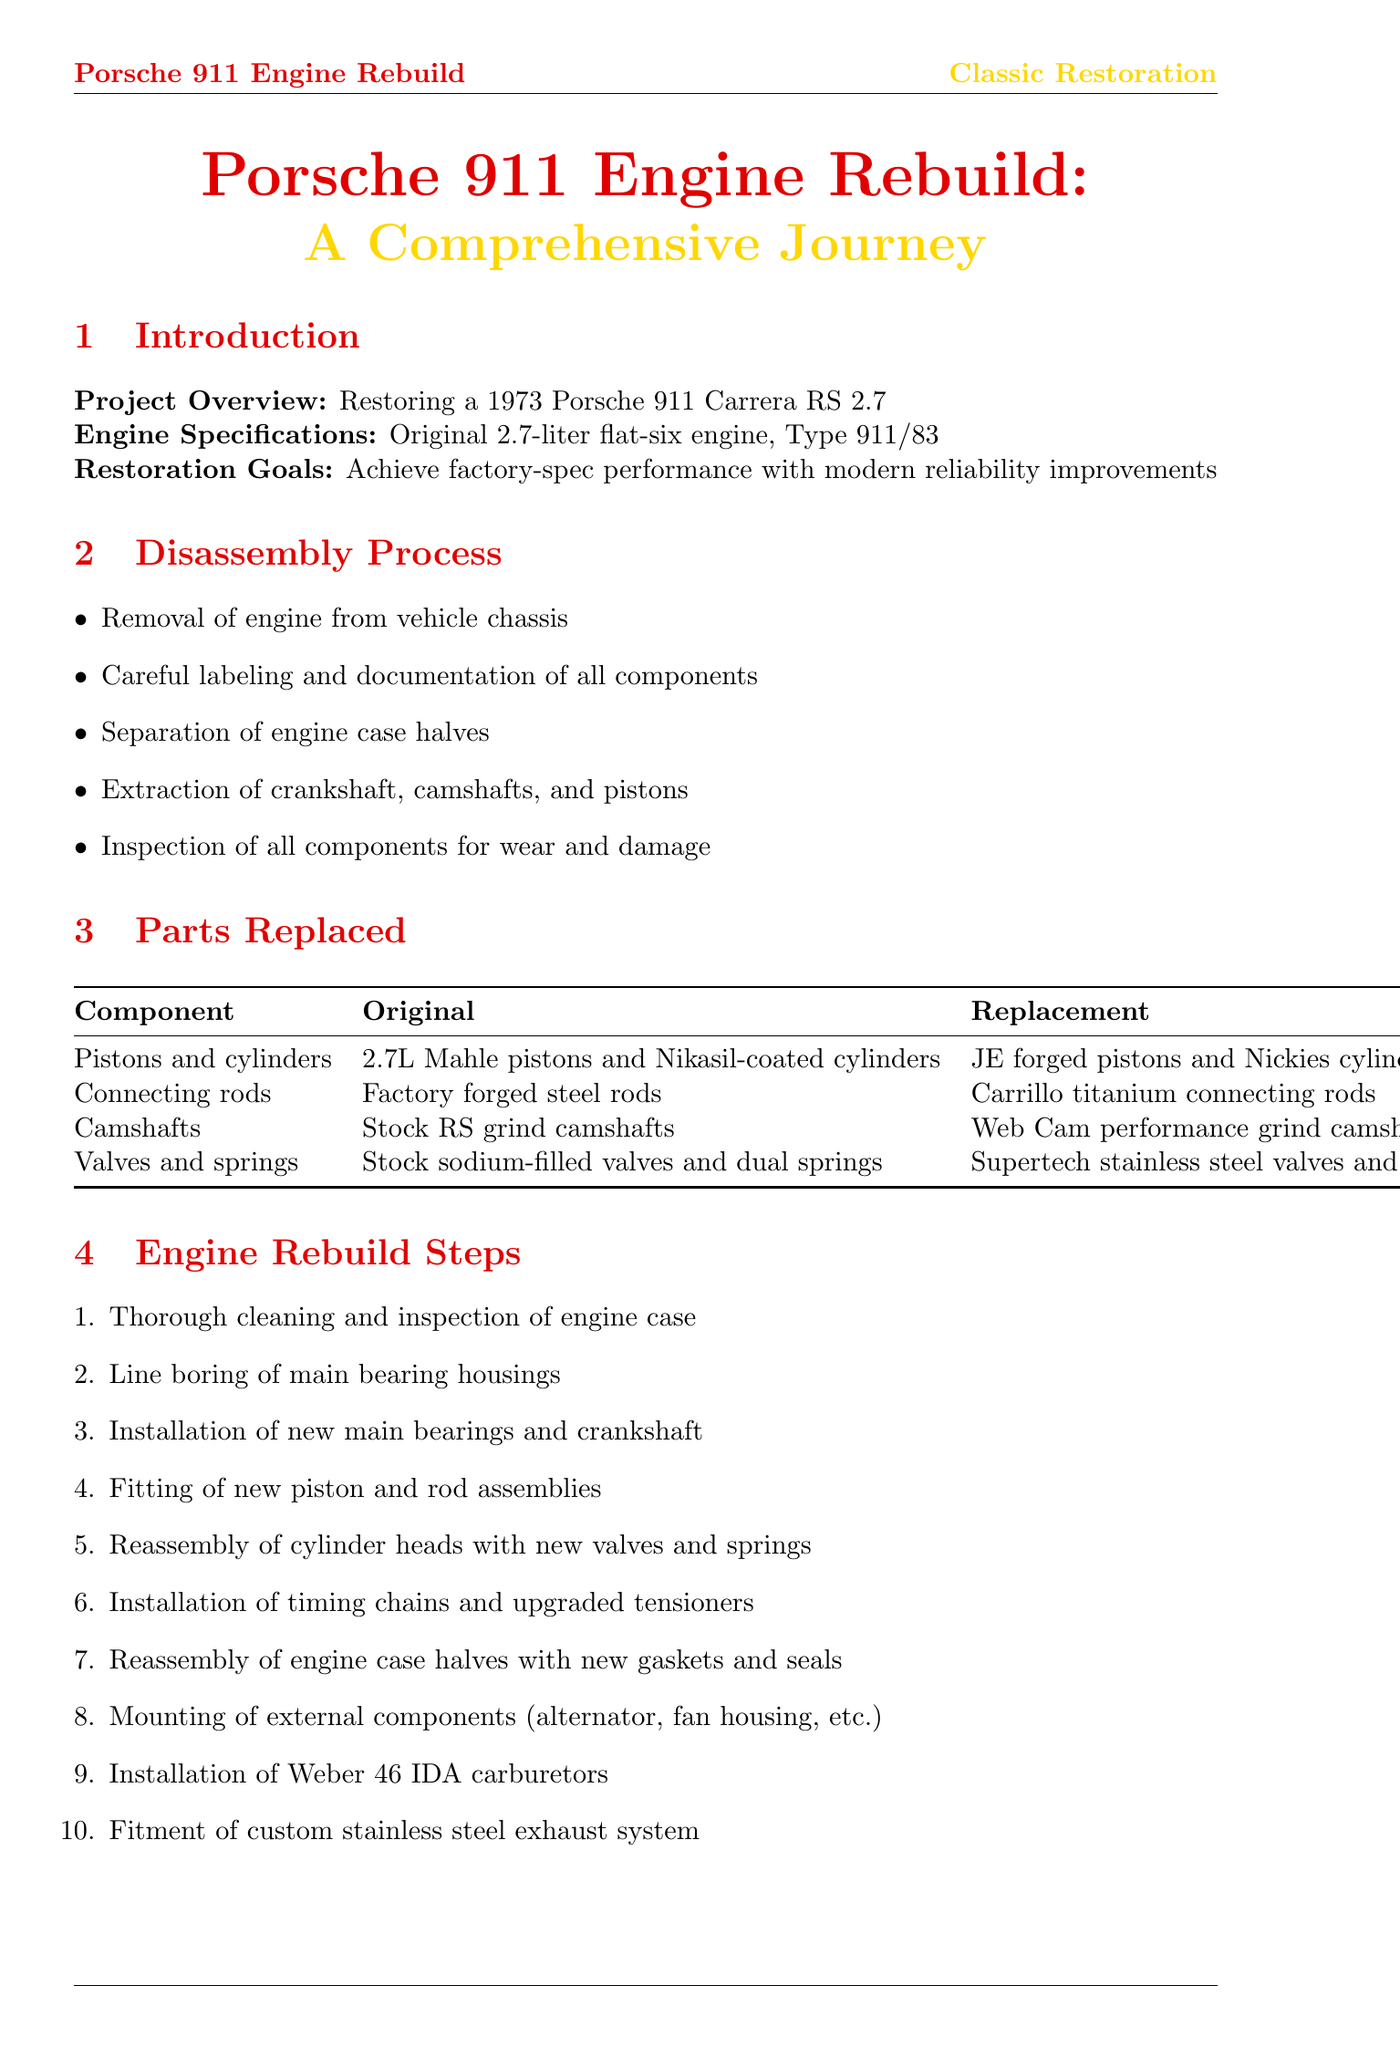What is the project overview? The project overview describes the restoration of a 1973 Porsche 911 Carrera RS 2.7.
Answer: Restoring a 1973 Porsche 911 Carrera RS 2.7 What is the original horsepower of the engine? The original horsepower of the engine is stated in the performance improvement section.
Answer: 210 hp at 6300 rpm Which connecting rods were replaced? The parts replaced section lists the original and replacement components, including connecting rods.
Answer: Carrillo titanium connecting rods What were the upgrades for the valves and springs? The table of replaced parts indicates the original and replacement components for valves and springs.
Answer: Supertech stainless steel valves and titanium retainers with upgraded valve springs What is the achieved torque after rebuild? The performance improvement section shows the torque values before and after the rebuild.
Answer: 215 lb-ft at 5500 rpm What was performed on the Mustang dynamometer? The testing and tuning section details the testing phases, including dynamometer sessions.
Answer: Multiple sessions on Mustang dynamometer for carburetor tuning What additional upgrade improves oil pressure? The additional upgrades section lists several improvements, including one for oil pressure.
Answer: Custom aluminum oil accumulator What is the future consideration for further optimization? The conclusion section mentions future potential enhancements for the engine.
Answer: Individual throttle bodies and engine management system 